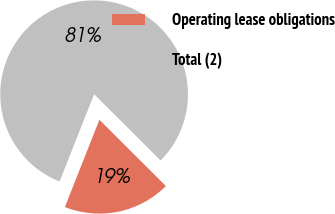Convert chart. <chart><loc_0><loc_0><loc_500><loc_500><pie_chart><fcel>Operating lease obligations<fcel>Total (2)<nl><fcel>18.52%<fcel>81.48%<nl></chart> 